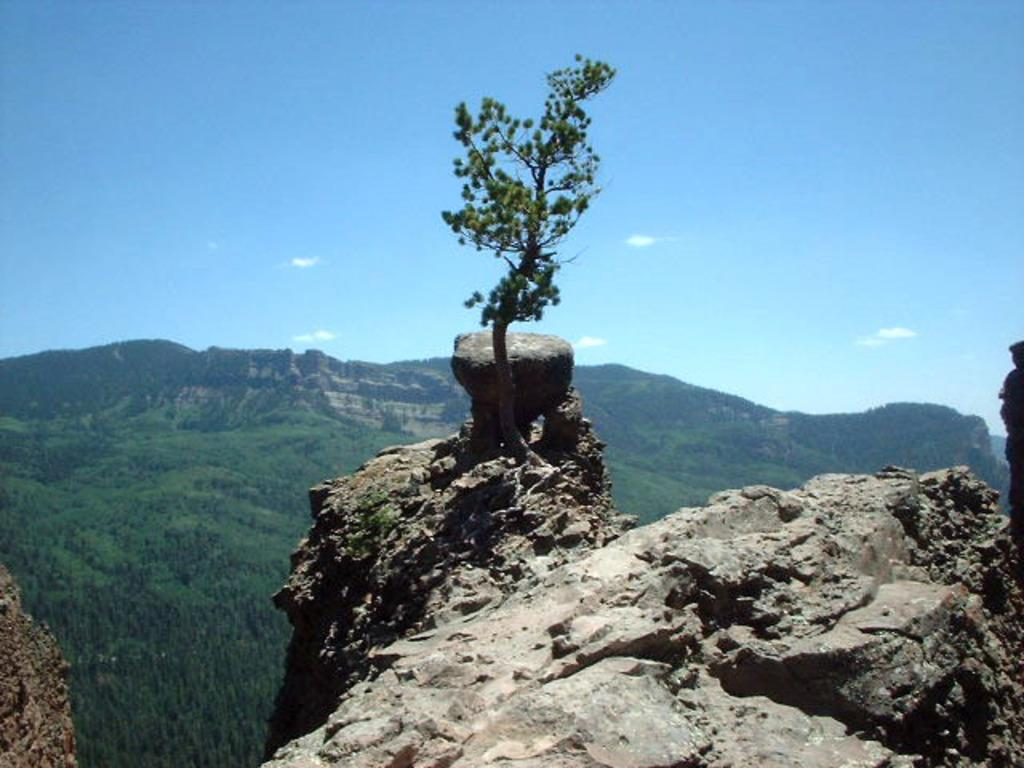What can be seen on the hills in the image? There are plants and stones on the hills in the image. What is visible in the background of the image? There is a group of trees and mountains visible in the background of the image. Additionally, the sky is visible, and it appears cloudy. Can you see a kite flying in the image? There is no kite present in the image. What type of dirt is visible on the plants in the image? The image does not show any dirt on the plants; it only shows plants and stones on the hills. 